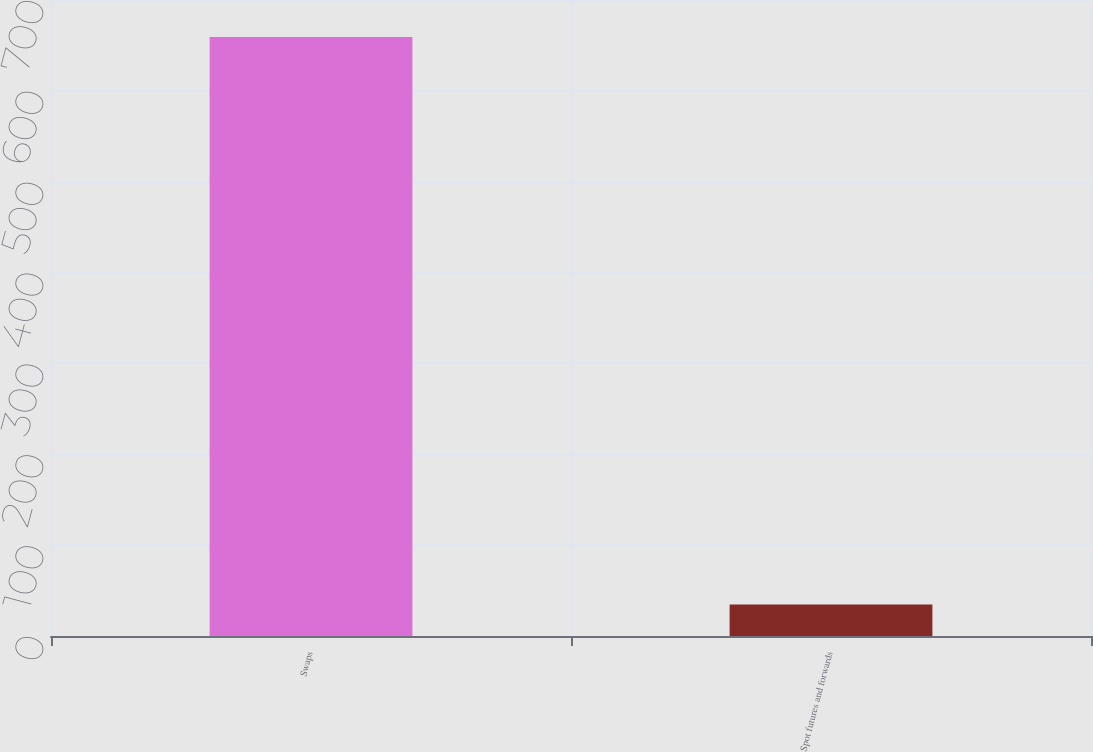Convert chart to OTSL. <chart><loc_0><loc_0><loc_500><loc_500><bar_chart><fcel>Swaps<fcel>Spot futures and forwards<nl><fcel>659.3<fcel>34.6<nl></chart> 